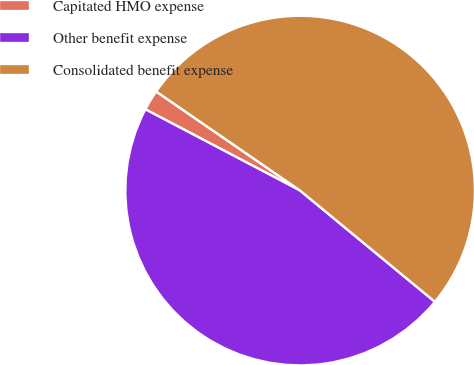<chart> <loc_0><loc_0><loc_500><loc_500><pie_chart><fcel>Capitated HMO expense<fcel>Other benefit expense<fcel>Consolidated benefit expense<nl><fcel>1.9%<fcel>46.72%<fcel>51.39%<nl></chart> 